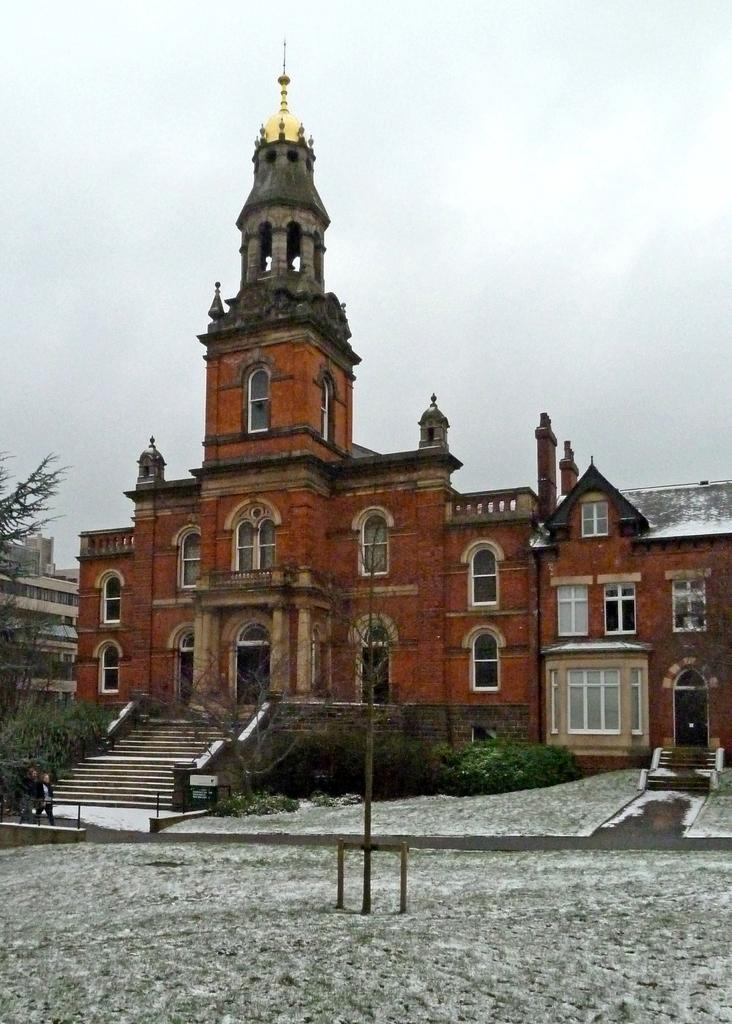What type of structures can be seen in the image? There are buildings in the image. What type of vegetation is present in the image? There are trees and shrubs in the image. Where are the two persons located in the image? The two persons are on the left side of the image. What type of education can be seen in the image? There is no reference to education in the image; it features buildings, trees, shrubs, and two persons. What color is the tongue of the person on the left side of the image? There is no tongue visible in the image, as the focus is on the buildings, trees, shrubs, and two persons. 